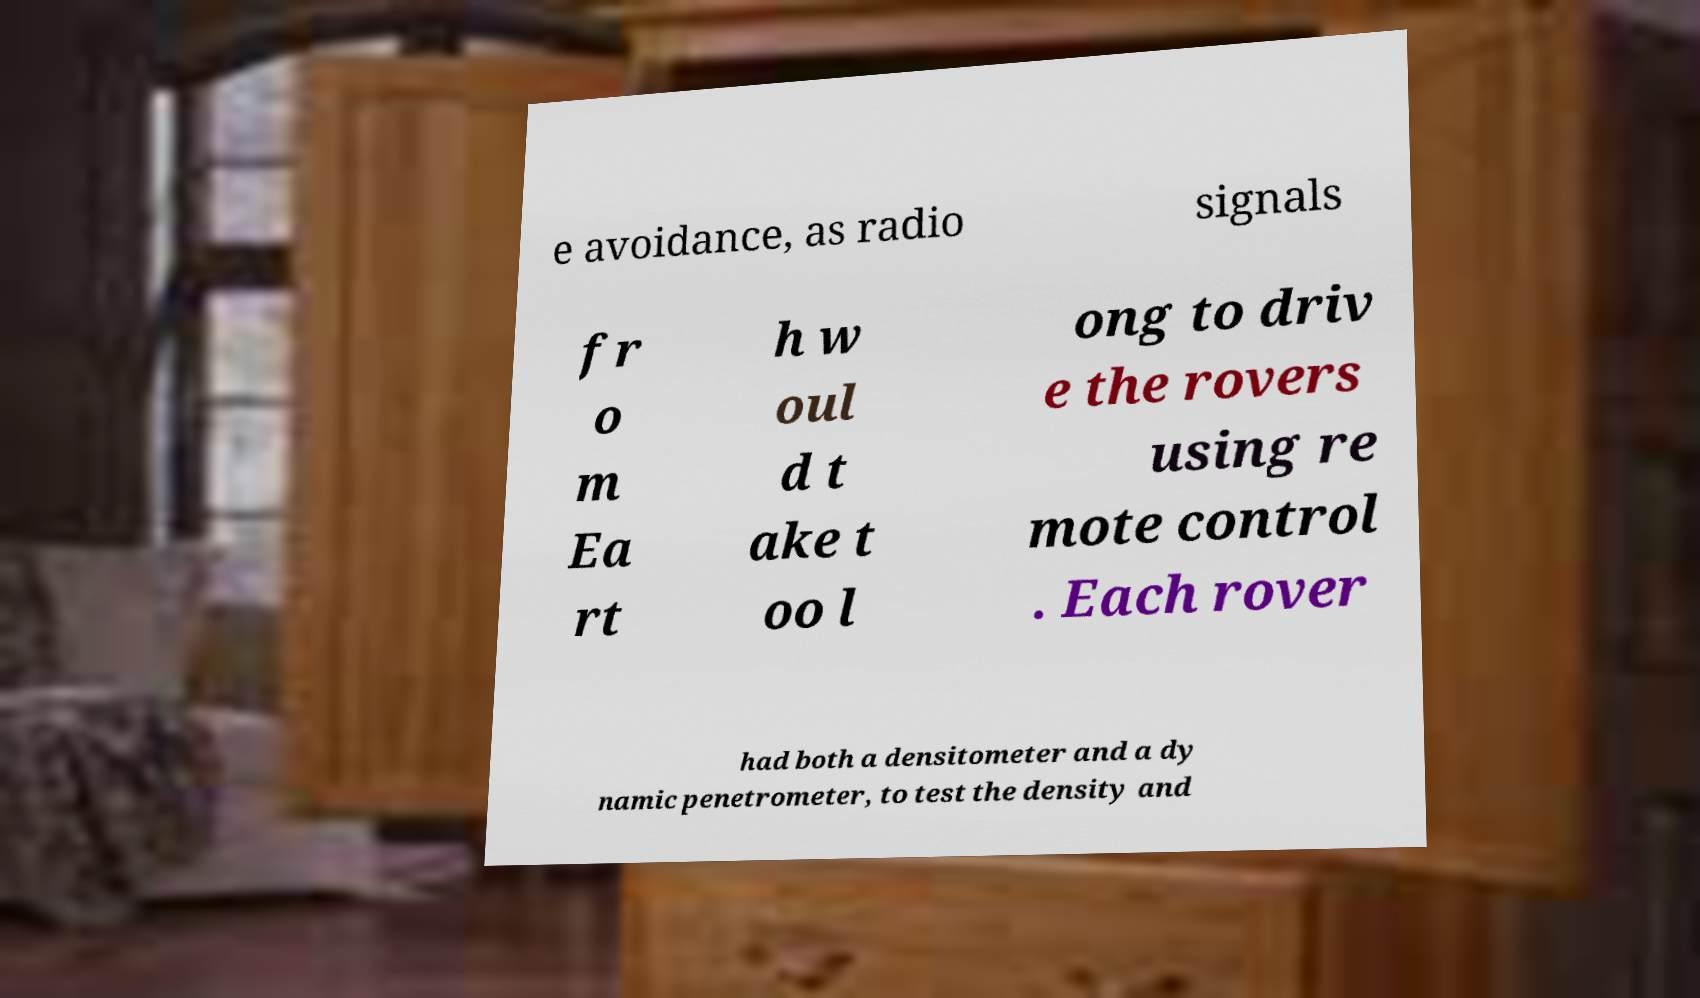Please identify and transcribe the text found in this image. e avoidance, as radio signals fr o m Ea rt h w oul d t ake t oo l ong to driv e the rovers using re mote control . Each rover had both a densitometer and a dy namic penetrometer, to test the density and 